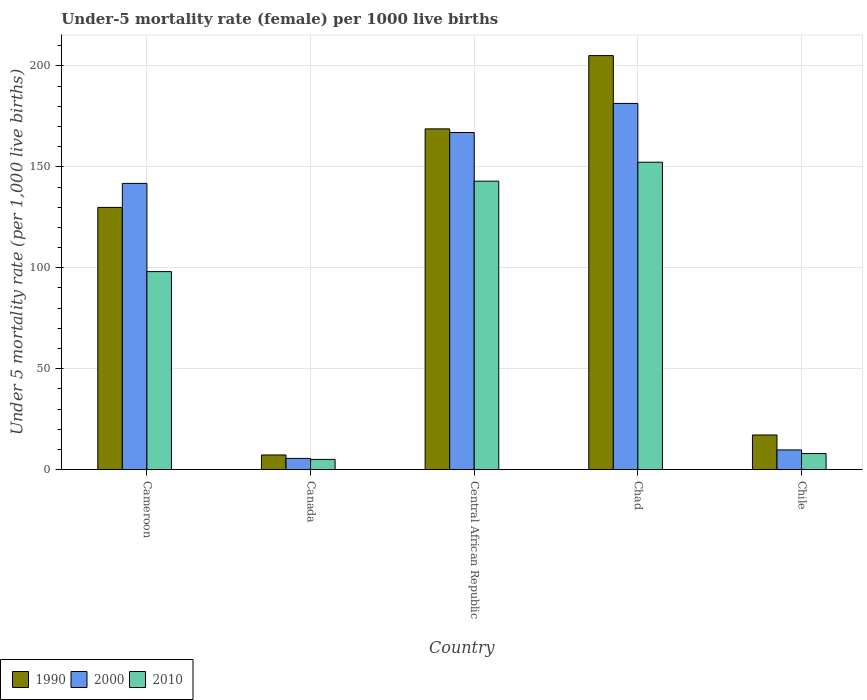How many different coloured bars are there?
Make the answer very short. 3. Are the number of bars on each tick of the X-axis equal?
Offer a very short reply. Yes. How many bars are there on the 1st tick from the left?
Provide a short and direct response. 3. How many bars are there on the 4th tick from the right?
Your response must be concise. 3. What is the label of the 3rd group of bars from the left?
Provide a succinct answer. Central African Republic. In how many cases, is the number of bars for a given country not equal to the number of legend labels?
Your response must be concise. 0. What is the under-five mortality rate in 1990 in Chile?
Provide a short and direct response. 17.2. Across all countries, what is the maximum under-five mortality rate in 2010?
Give a very brief answer. 152.3. Across all countries, what is the minimum under-five mortality rate in 2000?
Provide a succinct answer. 5.6. In which country was the under-five mortality rate in 2010 maximum?
Ensure brevity in your answer.  Chad. In which country was the under-five mortality rate in 2000 minimum?
Give a very brief answer. Canada. What is the total under-five mortality rate in 1990 in the graph?
Your answer should be very brief. 528.3. What is the difference between the under-five mortality rate in 2000 in Cameroon and that in Central African Republic?
Provide a succinct answer. -25.2. What is the difference between the under-five mortality rate in 2010 in Canada and the under-five mortality rate in 2000 in Cameroon?
Ensure brevity in your answer.  -136.7. What is the average under-five mortality rate in 2010 per country?
Provide a short and direct response. 81.28. What is the difference between the under-five mortality rate of/in 2010 and under-five mortality rate of/in 1990 in Chad?
Your answer should be compact. -52.8. What is the ratio of the under-five mortality rate in 2000 in Chad to that in Chile?
Provide a short and direct response. 18.51. Is the under-five mortality rate in 2000 in Canada less than that in Chile?
Keep it short and to the point. Yes. Is the difference between the under-five mortality rate in 2010 in Cameroon and Chile greater than the difference between the under-five mortality rate in 1990 in Cameroon and Chile?
Provide a short and direct response. No. What is the difference between the highest and the second highest under-five mortality rate in 1990?
Your response must be concise. 38.9. What is the difference between the highest and the lowest under-five mortality rate in 2010?
Provide a short and direct response. 147.2. How many bars are there?
Offer a terse response. 15. How many countries are there in the graph?
Your answer should be compact. 5. What is the difference between two consecutive major ticks on the Y-axis?
Your answer should be compact. 50. Does the graph contain any zero values?
Make the answer very short. No. Does the graph contain grids?
Give a very brief answer. Yes. Where does the legend appear in the graph?
Your response must be concise. Bottom left. How many legend labels are there?
Your answer should be very brief. 3. What is the title of the graph?
Give a very brief answer. Under-5 mortality rate (female) per 1000 live births. What is the label or title of the Y-axis?
Ensure brevity in your answer.  Under 5 mortality rate (per 1,0 live births). What is the Under 5 mortality rate (per 1,000 live births) of 1990 in Cameroon?
Ensure brevity in your answer.  129.9. What is the Under 5 mortality rate (per 1,000 live births) of 2000 in Cameroon?
Provide a short and direct response. 141.8. What is the Under 5 mortality rate (per 1,000 live births) of 2010 in Cameroon?
Offer a terse response. 98.1. What is the Under 5 mortality rate (per 1,000 live births) of 2010 in Canada?
Keep it short and to the point. 5.1. What is the Under 5 mortality rate (per 1,000 live births) in 1990 in Central African Republic?
Make the answer very short. 168.8. What is the Under 5 mortality rate (per 1,000 live births) of 2000 in Central African Republic?
Provide a succinct answer. 167. What is the Under 5 mortality rate (per 1,000 live births) in 2010 in Central African Republic?
Your response must be concise. 142.9. What is the Under 5 mortality rate (per 1,000 live births) of 1990 in Chad?
Ensure brevity in your answer.  205.1. What is the Under 5 mortality rate (per 1,000 live births) in 2000 in Chad?
Make the answer very short. 181.4. What is the Under 5 mortality rate (per 1,000 live births) of 2010 in Chad?
Your response must be concise. 152.3. What is the Under 5 mortality rate (per 1,000 live births) in 2000 in Chile?
Provide a succinct answer. 9.8. What is the Under 5 mortality rate (per 1,000 live births) in 2010 in Chile?
Offer a very short reply. 8. Across all countries, what is the maximum Under 5 mortality rate (per 1,000 live births) in 1990?
Make the answer very short. 205.1. Across all countries, what is the maximum Under 5 mortality rate (per 1,000 live births) in 2000?
Your answer should be very brief. 181.4. Across all countries, what is the maximum Under 5 mortality rate (per 1,000 live births) in 2010?
Offer a very short reply. 152.3. What is the total Under 5 mortality rate (per 1,000 live births) of 1990 in the graph?
Give a very brief answer. 528.3. What is the total Under 5 mortality rate (per 1,000 live births) of 2000 in the graph?
Provide a short and direct response. 505.6. What is the total Under 5 mortality rate (per 1,000 live births) of 2010 in the graph?
Give a very brief answer. 406.4. What is the difference between the Under 5 mortality rate (per 1,000 live births) of 1990 in Cameroon and that in Canada?
Make the answer very short. 122.6. What is the difference between the Under 5 mortality rate (per 1,000 live births) of 2000 in Cameroon and that in Canada?
Your answer should be very brief. 136.2. What is the difference between the Under 5 mortality rate (per 1,000 live births) in 2010 in Cameroon and that in Canada?
Give a very brief answer. 93. What is the difference between the Under 5 mortality rate (per 1,000 live births) of 1990 in Cameroon and that in Central African Republic?
Provide a succinct answer. -38.9. What is the difference between the Under 5 mortality rate (per 1,000 live births) in 2000 in Cameroon and that in Central African Republic?
Give a very brief answer. -25.2. What is the difference between the Under 5 mortality rate (per 1,000 live births) of 2010 in Cameroon and that in Central African Republic?
Your response must be concise. -44.8. What is the difference between the Under 5 mortality rate (per 1,000 live births) in 1990 in Cameroon and that in Chad?
Keep it short and to the point. -75.2. What is the difference between the Under 5 mortality rate (per 1,000 live births) in 2000 in Cameroon and that in Chad?
Your response must be concise. -39.6. What is the difference between the Under 5 mortality rate (per 1,000 live births) of 2010 in Cameroon and that in Chad?
Provide a short and direct response. -54.2. What is the difference between the Under 5 mortality rate (per 1,000 live births) of 1990 in Cameroon and that in Chile?
Offer a terse response. 112.7. What is the difference between the Under 5 mortality rate (per 1,000 live births) in 2000 in Cameroon and that in Chile?
Provide a succinct answer. 132. What is the difference between the Under 5 mortality rate (per 1,000 live births) in 2010 in Cameroon and that in Chile?
Ensure brevity in your answer.  90.1. What is the difference between the Under 5 mortality rate (per 1,000 live births) in 1990 in Canada and that in Central African Republic?
Your response must be concise. -161.5. What is the difference between the Under 5 mortality rate (per 1,000 live births) of 2000 in Canada and that in Central African Republic?
Provide a short and direct response. -161.4. What is the difference between the Under 5 mortality rate (per 1,000 live births) in 2010 in Canada and that in Central African Republic?
Your response must be concise. -137.8. What is the difference between the Under 5 mortality rate (per 1,000 live births) of 1990 in Canada and that in Chad?
Offer a very short reply. -197.8. What is the difference between the Under 5 mortality rate (per 1,000 live births) of 2000 in Canada and that in Chad?
Keep it short and to the point. -175.8. What is the difference between the Under 5 mortality rate (per 1,000 live births) in 2010 in Canada and that in Chad?
Ensure brevity in your answer.  -147.2. What is the difference between the Under 5 mortality rate (per 1,000 live births) of 1990 in Canada and that in Chile?
Your answer should be very brief. -9.9. What is the difference between the Under 5 mortality rate (per 1,000 live births) of 2000 in Canada and that in Chile?
Your answer should be compact. -4.2. What is the difference between the Under 5 mortality rate (per 1,000 live births) in 1990 in Central African Republic and that in Chad?
Provide a succinct answer. -36.3. What is the difference between the Under 5 mortality rate (per 1,000 live births) of 2000 in Central African Republic and that in Chad?
Your answer should be compact. -14.4. What is the difference between the Under 5 mortality rate (per 1,000 live births) in 1990 in Central African Republic and that in Chile?
Make the answer very short. 151.6. What is the difference between the Under 5 mortality rate (per 1,000 live births) in 2000 in Central African Republic and that in Chile?
Offer a terse response. 157.2. What is the difference between the Under 5 mortality rate (per 1,000 live births) of 2010 in Central African Republic and that in Chile?
Offer a very short reply. 134.9. What is the difference between the Under 5 mortality rate (per 1,000 live births) in 1990 in Chad and that in Chile?
Your answer should be compact. 187.9. What is the difference between the Under 5 mortality rate (per 1,000 live births) in 2000 in Chad and that in Chile?
Make the answer very short. 171.6. What is the difference between the Under 5 mortality rate (per 1,000 live births) in 2010 in Chad and that in Chile?
Ensure brevity in your answer.  144.3. What is the difference between the Under 5 mortality rate (per 1,000 live births) in 1990 in Cameroon and the Under 5 mortality rate (per 1,000 live births) in 2000 in Canada?
Offer a very short reply. 124.3. What is the difference between the Under 5 mortality rate (per 1,000 live births) of 1990 in Cameroon and the Under 5 mortality rate (per 1,000 live births) of 2010 in Canada?
Offer a terse response. 124.8. What is the difference between the Under 5 mortality rate (per 1,000 live births) of 2000 in Cameroon and the Under 5 mortality rate (per 1,000 live births) of 2010 in Canada?
Offer a very short reply. 136.7. What is the difference between the Under 5 mortality rate (per 1,000 live births) of 1990 in Cameroon and the Under 5 mortality rate (per 1,000 live births) of 2000 in Central African Republic?
Provide a short and direct response. -37.1. What is the difference between the Under 5 mortality rate (per 1,000 live births) of 1990 in Cameroon and the Under 5 mortality rate (per 1,000 live births) of 2010 in Central African Republic?
Make the answer very short. -13. What is the difference between the Under 5 mortality rate (per 1,000 live births) of 2000 in Cameroon and the Under 5 mortality rate (per 1,000 live births) of 2010 in Central African Republic?
Ensure brevity in your answer.  -1.1. What is the difference between the Under 5 mortality rate (per 1,000 live births) in 1990 in Cameroon and the Under 5 mortality rate (per 1,000 live births) in 2000 in Chad?
Your response must be concise. -51.5. What is the difference between the Under 5 mortality rate (per 1,000 live births) in 1990 in Cameroon and the Under 5 mortality rate (per 1,000 live births) in 2010 in Chad?
Provide a succinct answer. -22.4. What is the difference between the Under 5 mortality rate (per 1,000 live births) in 2000 in Cameroon and the Under 5 mortality rate (per 1,000 live births) in 2010 in Chad?
Offer a terse response. -10.5. What is the difference between the Under 5 mortality rate (per 1,000 live births) of 1990 in Cameroon and the Under 5 mortality rate (per 1,000 live births) of 2000 in Chile?
Give a very brief answer. 120.1. What is the difference between the Under 5 mortality rate (per 1,000 live births) of 1990 in Cameroon and the Under 5 mortality rate (per 1,000 live births) of 2010 in Chile?
Provide a succinct answer. 121.9. What is the difference between the Under 5 mortality rate (per 1,000 live births) of 2000 in Cameroon and the Under 5 mortality rate (per 1,000 live births) of 2010 in Chile?
Give a very brief answer. 133.8. What is the difference between the Under 5 mortality rate (per 1,000 live births) in 1990 in Canada and the Under 5 mortality rate (per 1,000 live births) in 2000 in Central African Republic?
Make the answer very short. -159.7. What is the difference between the Under 5 mortality rate (per 1,000 live births) in 1990 in Canada and the Under 5 mortality rate (per 1,000 live births) in 2010 in Central African Republic?
Your answer should be very brief. -135.6. What is the difference between the Under 5 mortality rate (per 1,000 live births) in 2000 in Canada and the Under 5 mortality rate (per 1,000 live births) in 2010 in Central African Republic?
Make the answer very short. -137.3. What is the difference between the Under 5 mortality rate (per 1,000 live births) of 1990 in Canada and the Under 5 mortality rate (per 1,000 live births) of 2000 in Chad?
Your answer should be compact. -174.1. What is the difference between the Under 5 mortality rate (per 1,000 live births) in 1990 in Canada and the Under 5 mortality rate (per 1,000 live births) in 2010 in Chad?
Your answer should be compact. -145. What is the difference between the Under 5 mortality rate (per 1,000 live births) in 2000 in Canada and the Under 5 mortality rate (per 1,000 live births) in 2010 in Chad?
Keep it short and to the point. -146.7. What is the difference between the Under 5 mortality rate (per 1,000 live births) in 1990 in Canada and the Under 5 mortality rate (per 1,000 live births) in 2000 in Chile?
Your answer should be very brief. -2.5. What is the difference between the Under 5 mortality rate (per 1,000 live births) in 1990 in Canada and the Under 5 mortality rate (per 1,000 live births) in 2010 in Chile?
Your answer should be compact. -0.7. What is the difference between the Under 5 mortality rate (per 1,000 live births) in 1990 in Central African Republic and the Under 5 mortality rate (per 1,000 live births) in 2000 in Chad?
Your response must be concise. -12.6. What is the difference between the Under 5 mortality rate (per 1,000 live births) of 1990 in Central African Republic and the Under 5 mortality rate (per 1,000 live births) of 2000 in Chile?
Offer a very short reply. 159. What is the difference between the Under 5 mortality rate (per 1,000 live births) in 1990 in Central African Republic and the Under 5 mortality rate (per 1,000 live births) in 2010 in Chile?
Provide a short and direct response. 160.8. What is the difference between the Under 5 mortality rate (per 1,000 live births) of 2000 in Central African Republic and the Under 5 mortality rate (per 1,000 live births) of 2010 in Chile?
Provide a short and direct response. 159. What is the difference between the Under 5 mortality rate (per 1,000 live births) of 1990 in Chad and the Under 5 mortality rate (per 1,000 live births) of 2000 in Chile?
Provide a short and direct response. 195.3. What is the difference between the Under 5 mortality rate (per 1,000 live births) in 1990 in Chad and the Under 5 mortality rate (per 1,000 live births) in 2010 in Chile?
Your response must be concise. 197.1. What is the difference between the Under 5 mortality rate (per 1,000 live births) in 2000 in Chad and the Under 5 mortality rate (per 1,000 live births) in 2010 in Chile?
Offer a very short reply. 173.4. What is the average Under 5 mortality rate (per 1,000 live births) in 1990 per country?
Your response must be concise. 105.66. What is the average Under 5 mortality rate (per 1,000 live births) in 2000 per country?
Your response must be concise. 101.12. What is the average Under 5 mortality rate (per 1,000 live births) of 2010 per country?
Your answer should be very brief. 81.28. What is the difference between the Under 5 mortality rate (per 1,000 live births) of 1990 and Under 5 mortality rate (per 1,000 live births) of 2000 in Cameroon?
Make the answer very short. -11.9. What is the difference between the Under 5 mortality rate (per 1,000 live births) of 1990 and Under 5 mortality rate (per 1,000 live births) of 2010 in Cameroon?
Give a very brief answer. 31.8. What is the difference between the Under 5 mortality rate (per 1,000 live births) in 2000 and Under 5 mortality rate (per 1,000 live births) in 2010 in Cameroon?
Your response must be concise. 43.7. What is the difference between the Under 5 mortality rate (per 1,000 live births) of 1990 and Under 5 mortality rate (per 1,000 live births) of 2010 in Canada?
Your answer should be very brief. 2.2. What is the difference between the Under 5 mortality rate (per 1,000 live births) of 2000 and Under 5 mortality rate (per 1,000 live births) of 2010 in Canada?
Your answer should be very brief. 0.5. What is the difference between the Under 5 mortality rate (per 1,000 live births) in 1990 and Under 5 mortality rate (per 1,000 live births) in 2000 in Central African Republic?
Your response must be concise. 1.8. What is the difference between the Under 5 mortality rate (per 1,000 live births) in 1990 and Under 5 mortality rate (per 1,000 live births) in 2010 in Central African Republic?
Your answer should be very brief. 25.9. What is the difference between the Under 5 mortality rate (per 1,000 live births) of 2000 and Under 5 mortality rate (per 1,000 live births) of 2010 in Central African Republic?
Your answer should be very brief. 24.1. What is the difference between the Under 5 mortality rate (per 1,000 live births) in 1990 and Under 5 mortality rate (per 1,000 live births) in 2000 in Chad?
Provide a succinct answer. 23.7. What is the difference between the Under 5 mortality rate (per 1,000 live births) in 1990 and Under 5 mortality rate (per 1,000 live births) in 2010 in Chad?
Provide a short and direct response. 52.8. What is the difference between the Under 5 mortality rate (per 1,000 live births) in 2000 and Under 5 mortality rate (per 1,000 live births) in 2010 in Chad?
Ensure brevity in your answer.  29.1. What is the difference between the Under 5 mortality rate (per 1,000 live births) in 1990 and Under 5 mortality rate (per 1,000 live births) in 2000 in Chile?
Keep it short and to the point. 7.4. What is the ratio of the Under 5 mortality rate (per 1,000 live births) of 1990 in Cameroon to that in Canada?
Make the answer very short. 17.79. What is the ratio of the Under 5 mortality rate (per 1,000 live births) of 2000 in Cameroon to that in Canada?
Keep it short and to the point. 25.32. What is the ratio of the Under 5 mortality rate (per 1,000 live births) in 2010 in Cameroon to that in Canada?
Give a very brief answer. 19.24. What is the ratio of the Under 5 mortality rate (per 1,000 live births) of 1990 in Cameroon to that in Central African Republic?
Your response must be concise. 0.77. What is the ratio of the Under 5 mortality rate (per 1,000 live births) of 2000 in Cameroon to that in Central African Republic?
Your answer should be very brief. 0.85. What is the ratio of the Under 5 mortality rate (per 1,000 live births) in 2010 in Cameroon to that in Central African Republic?
Offer a very short reply. 0.69. What is the ratio of the Under 5 mortality rate (per 1,000 live births) in 1990 in Cameroon to that in Chad?
Give a very brief answer. 0.63. What is the ratio of the Under 5 mortality rate (per 1,000 live births) in 2000 in Cameroon to that in Chad?
Ensure brevity in your answer.  0.78. What is the ratio of the Under 5 mortality rate (per 1,000 live births) of 2010 in Cameroon to that in Chad?
Keep it short and to the point. 0.64. What is the ratio of the Under 5 mortality rate (per 1,000 live births) in 1990 in Cameroon to that in Chile?
Offer a very short reply. 7.55. What is the ratio of the Under 5 mortality rate (per 1,000 live births) in 2000 in Cameroon to that in Chile?
Make the answer very short. 14.47. What is the ratio of the Under 5 mortality rate (per 1,000 live births) of 2010 in Cameroon to that in Chile?
Your answer should be compact. 12.26. What is the ratio of the Under 5 mortality rate (per 1,000 live births) of 1990 in Canada to that in Central African Republic?
Offer a very short reply. 0.04. What is the ratio of the Under 5 mortality rate (per 1,000 live births) in 2000 in Canada to that in Central African Republic?
Make the answer very short. 0.03. What is the ratio of the Under 5 mortality rate (per 1,000 live births) in 2010 in Canada to that in Central African Republic?
Offer a very short reply. 0.04. What is the ratio of the Under 5 mortality rate (per 1,000 live births) in 1990 in Canada to that in Chad?
Offer a terse response. 0.04. What is the ratio of the Under 5 mortality rate (per 1,000 live births) in 2000 in Canada to that in Chad?
Your answer should be very brief. 0.03. What is the ratio of the Under 5 mortality rate (per 1,000 live births) in 2010 in Canada to that in Chad?
Your answer should be very brief. 0.03. What is the ratio of the Under 5 mortality rate (per 1,000 live births) of 1990 in Canada to that in Chile?
Offer a very short reply. 0.42. What is the ratio of the Under 5 mortality rate (per 1,000 live births) of 2000 in Canada to that in Chile?
Offer a very short reply. 0.57. What is the ratio of the Under 5 mortality rate (per 1,000 live births) in 2010 in Canada to that in Chile?
Offer a very short reply. 0.64. What is the ratio of the Under 5 mortality rate (per 1,000 live births) of 1990 in Central African Republic to that in Chad?
Your response must be concise. 0.82. What is the ratio of the Under 5 mortality rate (per 1,000 live births) of 2000 in Central African Republic to that in Chad?
Make the answer very short. 0.92. What is the ratio of the Under 5 mortality rate (per 1,000 live births) of 2010 in Central African Republic to that in Chad?
Your answer should be compact. 0.94. What is the ratio of the Under 5 mortality rate (per 1,000 live births) of 1990 in Central African Republic to that in Chile?
Your answer should be compact. 9.81. What is the ratio of the Under 5 mortality rate (per 1,000 live births) in 2000 in Central African Republic to that in Chile?
Provide a short and direct response. 17.04. What is the ratio of the Under 5 mortality rate (per 1,000 live births) in 2010 in Central African Republic to that in Chile?
Offer a terse response. 17.86. What is the ratio of the Under 5 mortality rate (per 1,000 live births) of 1990 in Chad to that in Chile?
Your answer should be very brief. 11.92. What is the ratio of the Under 5 mortality rate (per 1,000 live births) of 2000 in Chad to that in Chile?
Make the answer very short. 18.51. What is the ratio of the Under 5 mortality rate (per 1,000 live births) in 2010 in Chad to that in Chile?
Give a very brief answer. 19.04. What is the difference between the highest and the second highest Under 5 mortality rate (per 1,000 live births) of 1990?
Your answer should be very brief. 36.3. What is the difference between the highest and the second highest Under 5 mortality rate (per 1,000 live births) of 2000?
Offer a very short reply. 14.4. What is the difference between the highest and the lowest Under 5 mortality rate (per 1,000 live births) of 1990?
Provide a short and direct response. 197.8. What is the difference between the highest and the lowest Under 5 mortality rate (per 1,000 live births) in 2000?
Your answer should be very brief. 175.8. What is the difference between the highest and the lowest Under 5 mortality rate (per 1,000 live births) in 2010?
Keep it short and to the point. 147.2. 